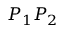<formula> <loc_0><loc_0><loc_500><loc_500>P _ { 1 } P _ { 2 }</formula> 